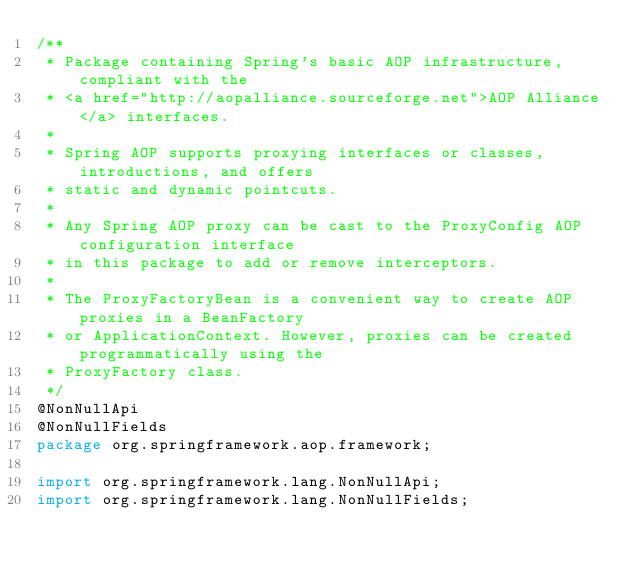Convert code to text. <code><loc_0><loc_0><loc_500><loc_500><_Java_>/**
 * Package containing Spring's basic AOP infrastructure, compliant with the
 * <a href="http://aopalliance.sourceforge.net">AOP Alliance</a> interfaces.
 *
 * Spring AOP supports proxying interfaces or classes, introductions, and offers
 * static and dynamic pointcuts.
 *
 * Any Spring AOP proxy can be cast to the ProxyConfig AOP configuration interface
 * in this package to add or remove interceptors.
 *
 * The ProxyFactoryBean is a convenient way to create AOP proxies in a BeanFactory
 * or ApplicationContext. However, proxies can be created programmatically using the
 * ProxyFactory class.
 */
@NonNullApi
@NonNullFields
package org.springframework.aop.framework;

import org.springframework.lang.NonNullApi;
import org.springframework.lang.NonNullFields;
</code> 